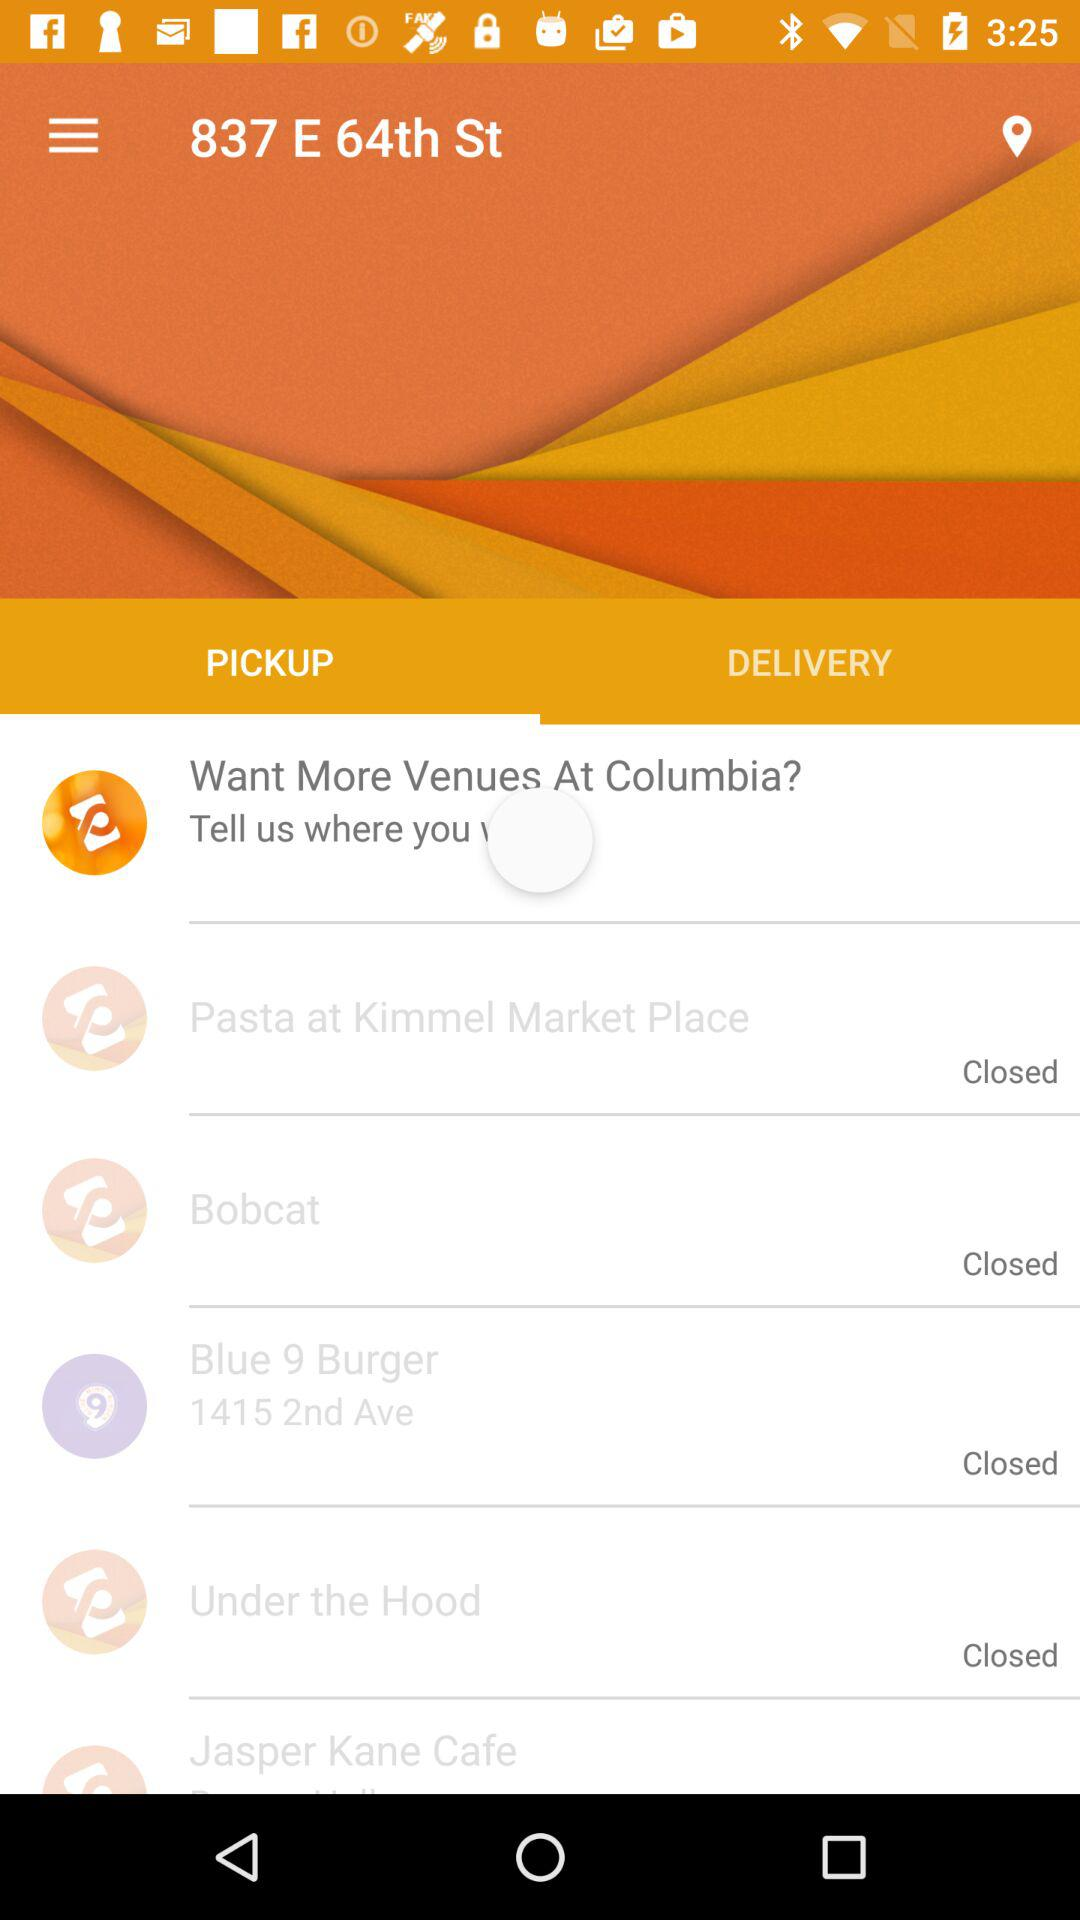Which tab is selected? The selected tab is "PICKUP". 